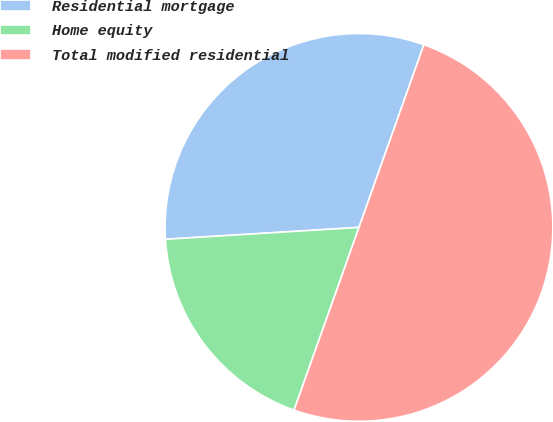Convert chart to OTSL. <chart><loc_0><loc_0><loc_500><loc_500><pie_chart><fcel>Residential mortgage<fcel>Home equity<fcel>Total modified residential<nl><fcel>31.41%<fcel>18.59%<fcel>50.0%<nl></chart> 